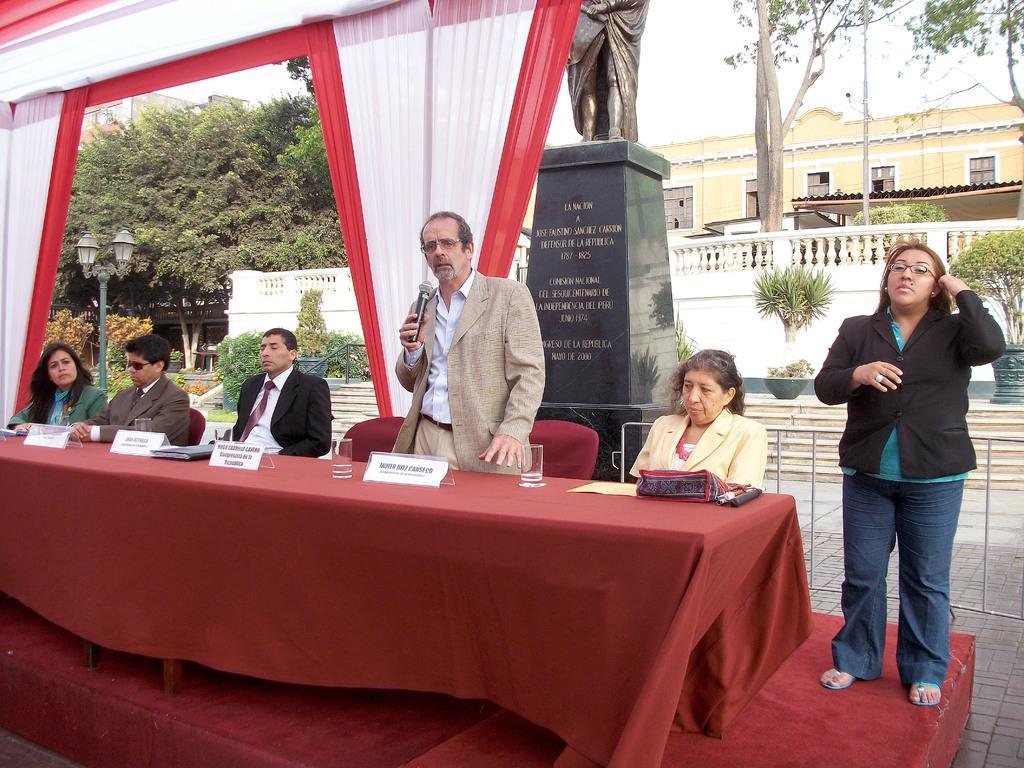Can you describe this image briefly? At the top of the picture we can see sky and trees. On the background we can see building with windows. This is a wall. Here we can see few plants. In Front portion of the picture we can see a platform and here we can see a table with a red cloth on it. These are the name boards. Here we can one man standing and holding a mike on his hand s and giving a speech and four persons are sitting on the chairs. On the right side of the picture there is one women standing wearing a black blazer. Behind to this man there is a statue. This is a white and red cloth decoration behind the platform. 